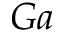<formula> <loc_0><loc_0><loc_500><loc_500>G a</formula> 